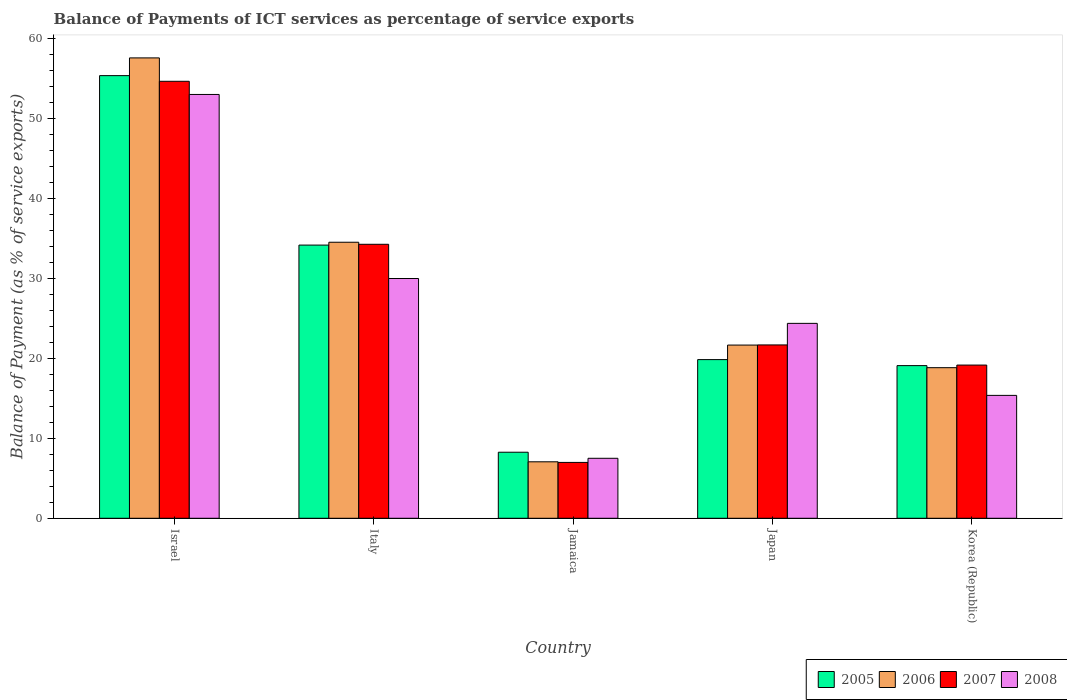Are the number of bars on each tick of the X-axis equal?
Give a very brief answer. Yes. What is the label of the 3rd group of bars from the left?
Give a very brief answer. Jamaica. What is the balance of payments of ICT services in 2006 in Korea (Republic)?
Provide a short and direct response. 18.84. Across all countries, what is the maximum balance of payments of ICT services in 2007?
Provide a succinct answer. 54.67. Across all countries, what is the minimum balance of payments of ICT services in 2007?
Offer a terse response. 6.99. In which country was the balance of payments of ICT services in 2006 maximum?
Give a very brief answer. Israel. In which country was the balance of payments of ICT services in 2005 minimum?
Give a very brief answer. Jamaica. What is the total balance of payments of ICT services in 2008 in the graph?
Ensure brevity in your answer.  130.27. What is the difference between the balance of payments of ICT services in 2007 in Israel and that in Japan?
Make the answer very short. 32.98. What is the difference between the balance of payments of ICT services in 2005 in Italy and the balance of payments of ICT services in 2007 in Korea (Republic)?
Provide a succinct answer. 15.01. What is the average balance of payments of ICT services in 2007 per country?
Provide a short and direct response. 27.36. What is the difference between the balance of payments of ICT services of/in 2008 and balance of payments of ICT services of/in 2006 in Japan?
Offer a terse response. 2.72. What is the ratio of the balance of payments of ICT services in 2007 in Israel to that in Korea (Republic)?
Provide a short and direct response. 2.85. Is the balance of payments of ICT services in 2006 in Italy less than that in Jamaica?
Offer a terse response. No. What is the difference between the highest and the second highest balance of payments of ICT services in 2005?
Make the answer very short. 14.33. What is the difference between the highest and the lowest balance of payments of ICT services in 2006?
Your answer should be very brief. 50.53. Is it the case that in every country, the sum of the balance of payments of ICT services in 2008 and balance of payments of ICT services in 2007 is greater than the balance of payments of ICT services in 2005?
Keep it short and to the point. Yes. How many bars are there?
Your answer should be compact. 20. Are all the bars in the graph horizontal?
Offer a very short reply. No. How many countries are there in the graph?
Offer a very short reply. 5. What is the difference between two consecutive major ticks on the Y-axis?
Provide a short and direct response. 10. Does the graph contain any zero values?
Ensure brevity in your answer.  No. Where does the legend appear in the graph?
Your answer should be very brief. Bottom right. How are the legend labels stacked?
Your answer should be very brief. Horizontal. What is the title of the graph?
Offer a terse response. Balance of Payments of ICT services as percentage of service exports. What is the label or title of the Y-axis?
Make the answer very short. Balance of Payment (as % of service exports). What is the Balance of Payment (as % of service exports) in 2005 in Israel?
Provide a short and direct response. 55.37. What is the Balance of Payment (as % of service exports) of 2006 in Israel?
Make the answer very short. 57.59. What is the Balance of Payment (as % of service exports) of 2007 in Israel?
Keep it short and to the point. 54.67. What is the Balance of Payment (as % of service exports) in 2008 in Israel?
Offer a terse response. 53.02. What is the Balance of Payment (as % of service exports) in 2005 in Italy?
Ensure brevity in your answer.  34.17. What is the Balance of Payment (as % of service exports) of 2006 in Italy?
Make the answer very short. 34.53. What is the Balance of Payment (as % of service exports) in 2007 in Italy?
Give a very brief answer. 34.28. What is the Balance of Payment (as % of service exports) in 2008 in Italy?
Your response must be concise. 29.99. What is the Balance of Payment (as % of service exports) in 2005 in Jamaica?
Provide a succinct answer. 8.26. What is the Balance of Payment (as % of service exports) in 2006 in Jamaica?
Give a very brief answer. 7.06. What is the Balance of Payment (as % of service exports) in 2007 in Jamaica?
Give a very brief answer. 6.99. What is the Balance of Payment (as % of service exports) of 2008 in Jamaica?
Offer a very short reply. 7.5. What is the Balance of Payment (as % of service exports) in 2005 in Japan?
Keep it short and to the point. 19.85. What is the Balance of Payment (as % of service exports) of 2006 in Japan?
Your answer should be compact. 21.67. What is the Balance of Payment (as % of service exports) in 2007 in Japan?
Keep it short and to the point. 21.69. What is the Balance of Payment (as % of service exports) of 2008 in Japan?
Make the answer very short. 24.38. What is the Balance of Payment (as % of service exports) in 2005 in Korea (Republic)?
Your answer should be very brief. 19.1. What is the Balance of Payment (as % of service exports) in 2006 in Korea (Republic)?
Give a very brief answer. 18.84. What is the Balance of Payment (as % of service exports) of 2007 in Korea (Republic)?
Provide a succinct answer. 19.16. What is the Balance of Payment (as % of service exports) in 2008 in Korea (Republic)?
Give a very brief answer. 15.37. Across all countries, what is the maximum Balance of Payment (as % of service exports) in 2005?
Keep it short and to the point. 55.37. Across all countries, what is the maximum Balance of Payment (as % of service exports) in 2006?
Ensure brevity in your answer.  57.59. Across all countries, what is the maximum Balance of Payment (as % of service exports) of 2007?
Keep it short and to the point. 54.67. Across all countries, what is the maximum Balance of Payment (as % of service exports) in 2008?
Provide a short and direct response. 53.02. Across all countries, what is the minimum Balance of Payment (as % of service exports) of 2005?
Make the answer very short. 8.26. Across all countries, what is the minimum Balance of Payment (as % of service exports) of 2006?
Give a very brief answer. 7.06. Across all countries, what is the minimum Balance of Payment (as % of service exports) in 2007?
Make the answer very short. 6.99. Across all countries, what is the minimum Balance of Payment (as % of service exports) in 2008?
Your response must be concise. 7.5. What is the total Balance of Payment (as % of service exports) in 2005 in the graph?
Provide a succinct answer. 136.76. What is the total Balance of Payment (as % of service exports) in 2006 in the graph?
Give a very brief answer. 139.69. What is the total Balance of Payment (as % of service exports) in 2007 in the graph?
Your answer should be very brief. 136.78. What is the total Balance of Payment (as % of service exports) of 2008 in the graph?
Make the answer very short. 130.27. What is the difference between the Balance of Payment (as % of service exports) of 2005 in Israel and that in Italy?
Offer a terse response. 21.2. What is the difference between the Balance of Payment (as % of service exports) in 2006 in Israel and that in Italy?
Your answer should be compact. 23.06. What is the difference between the Balance of Payment (as % of service exports) of 2007 in Israel and that in Italy?
Offer a terse response. 20.39. What is the difference between the Balance of Payment (as % of service exports) in 2008 in Israel and that in Italy?
Keep it short and to the point. 23.02. What is the difference between the Balance of Payment (as % of service exports) in 2005 in Israel and that in Jamaica?
Offer a terse response. 47.11. What is the difference between the Balance of Payment (as % of service exports) of 2006 in Israel and that in Jamaica?
Give a very brief answer. 50.53. What is the difference between the Balance of Payment (as % of service exports) of 2007 in Israel and that in Jamaica?
Offer a terse response. 47.68. What is the difference between the Balance of Payment (as % of service exports) in 2008 in Israel and that in Jamaica?
Offer a very short reply. 45.51. What is the difference between the Balance of Payment (as % of service exports) of 2005 in Israel and that in Japan?
Make the answer very short. 35.52. What is the difference between the Balance of Payment (as % of service exports) in 2006 in Israel and that in Japan?
Give a very brief answer. 35.93. What is the difference between the Balance of Payment (as % of service exports) of 2007 in Israel and that in Japan?
Offer a very short reply. 32.98. What is the difference between the Balance of Payment (as % of service exports) in 2008 in Israel and that in Japan?
Your answer should be very brief. 28.64. What is the difference between the Balance of Payment (as % of service exports) in 2005 in Israel and that in Korea (Republic)?
Offer a very short reply. 36.28. What is the difference between the Balance of Payment (as % of service exports) of 2006 in Israel and that in Korea (Republic)?
Provide a short and direct response. 38.75. What is the difference between the Balance of Payment (as % of service exports) of 2007 in Israel and that in Korea (Republic)?
Give a very brief answer. 35.5. What is the difference between the Balance of Payment (as % of service exports) of 2008 in Israel and that in Korea (Republic)?
Make the answer very short. 37.64. What is the difference between the Balance of Payment (as % of service exports) of 2005 in Italy and that in Jamaica?
Keep it short and to the point. 25.91. What is the difference between the Balance of Payment (as % of service exports) in 2006 in Italy and that in Jamaica?
Offer a terse response. 27.47. What is the difference between the Balance of Payment (as % of service exports) in 2007 in Italy and that in Jamaica?
Keep it short and to the point. 27.29. What is the difference between the Balance of Payment (as % of service exports) in 2008 in Italy and that in Jamaica?
Your answer should be compact. 22.49. What is the difference between the Balance of Payment (as % of service exports) in 2005 in Italy and that in Japan?
Your response must be concise. 14.33. What is the difference between the Balance of Payment (as % of service exports) of 2006 in Italy and that in Japan?
Provide a succinct answer. 12.87. What is the difference between the Balance of Payment (as % of service exports) in 2007 in Italy and that in Japan?
Your answer should be compact. 12.59. What is the difference between the Balance of Payment (as % of service exports) of 2008 in Italy and that in Japan?
Provide a succinct answer. 5.61. What is the difference between the Balance of Payment (as % of service exports) of 2005 in Italy and that in Korea (Republic)?
Keep it short and to the point. 15.08. What is the difference between the Balance of Payment (as % of service exports) of 2006 in Italy and that in Korea (Republic)?
Ensure brevity in your answer.  15.69. What is the difference between the Balance of Payment (as % of service exports) in 2007 in Italy and that in Korea (Republic)?
Provide a succinct answer. 15.11. What is the difference between the Balance of Payment (as % of service exports) of 2008 in Italy and that in Korea (Republic)?
Make the answer very short. 14.62. What is the difference between the Balance of Payment (as % of service exports) of 2005 in Jamaica and that in Japan?
Keep it short and to the point. -11.59. What is the difference between the Balance of Payment (as % of service exports) in 2006 in Jamaica and that in Japan?
Give a very brief answer. -14.6. What is the difference between the Balance of Payment (as % of service exports) of 2007 in Jamaica and that in Japan?
Offer a very short reply. -14.7. What is the difference between the Balance of Payment (as % of service exports) in 2008 in Jamaica and that in Japan?
Provide a succinct answer. -16.88. What is the difference between the Balance of Payment (as % of service exports) of 2005 in Jamaica and that in Korea (Republic)?
Provide a short and direct response. -10.83. What is the difference between the Balance of Payment (as % of service exports) in 2006 in Jamaica and that in Korea (Republic)?
Make the answer very short. -11.78. What is the difference between the Balance of Payment (as % of service exports) of 2007 in Jamaica and that in Korea (Republic)?
Your answer should be very brief. -12.18. What is the difference between the Balance of Payment (as % of service exports) of 2008 in Jamaica and that in Korea (Republic)?
Provide a succinct answer. -7.87. What is the difference between the Balance of Payment (as % of service exports) in 2005 in Japan and that in Korea (Republic)?
Your response must be concise. 0.75. What is the difference between the Balance of Payment (as % of service exports) in 2006 in Japan and that in Korea (Republic)?
Give a very brief answer. 2.83. What is the difference between the Balance of Payment (as % of service exports) of 2007 in Japan and that in Korea (Republic)?
Your response must be concise. 2.52. What is the difference between the Balance of Payment (as % of service exports) in 2008 in Japan and that in Korea (Republic)?
Ensure brevity in your answer.  9.01. What is the difference between the Balance of Payment (as % of service exports) in 2005 in Israel and the Balance of Payment (as % of service exports) in 2006 in Italy?
Give a very brief answer. 20.84. What is the difference between the Balance of Payment (as % of service exports) of 2005 in Israel and the Balance of Payment (as % of service exports) of 2007 in Italy?
Provide a short and direct response. 21.1. What is the difference between the Balance of Payment (as % of service exports) of 2005 in Israel and the Balance of Payment (as % of service exports) of 2008 in Italy?
Provide a short and direct response. 25.38. What is the difference between the Balance of Payment (as % of service exports) in 2006 in Israel and the Balance of Payment (as % of service exports) in 2007 in Italy?
Your answer should be compact. 23.32. What is the difference between the Balance of Payment (as % of service exports) in 2006 in Israel and the Balance of Payment (as % of service exports) in 2008 in Italy?
Make the answer very short. 27.6. What is the difference between the Balance of Payment (as % of service exports) of 2007 in Israel and the Balance of Payment (as % of service exports) of 2008 in Italy?
Your answer should be compact. 24.67. What is the difference between the Balance of Payment (as % of service exports) in 2005 in Israel and the Balance of Payment (as % of service exports) in 2006 in Jamaica?
Keep it short and to the point. 48.31. What is the difference between the Balance of Payment (as % of service exports) of 2005 in Israel and the Balance of Payment (as % of service exports) of 2007 in Jamaica?
Provide a succinct answer. 48.39. What is the difference between the Balance of Payment (as % of service exports) in 2005 in Israel and the Balance of Payment (as % of service exports) in 2008 in Jamaica?
Make the answer very short. 47.87. What is the difference between the Balance of Payment (as % of service exports) of 2006 in Israel and the Balance of Payment (as % of service exports) of 2007 in Jamaica?
Your answer should be very brief. 50.61. What is the difference between the Balance of Payment (as % of service exports) in 2006 in Israel and the Balance of Payment (as % of service exports) in 2008 in Jamaica?
Keep it short and to the point. 50.09. What is the difference between the Balance of Payment (as % of service exports) of 2007 in Israel and the Balance of Payment (as % of service exports) of 2008 in Jamaica?
Ensure brevity in your answer.  47.16. What is the difference between the Balance of Payment (as % of service exports) in 2005 in Israel and the Balance of Payment (as % of service exports) in 2006 in Japan?
Your response must be concise. 33.71. What is the difference between the Balance of Payment (as % of service exports) of 2005 in Israel and the Balance of Payment (as % of service exports) of 2007 in Japan?
Offer a terse response. 33.69. What is the difference between the Balance of Payment (as % of service exports) in 2005 in Israel and the Balance of Payment (as % of service exports) in 2008 in Japan?
Make the answer very short. 30.99. What is the difference between the Balance of Payment (as % of service exports) in 2006 in Israel and the Balance of Payment (as % of service exports) in 2007 in Japan?
Your answer should be very brief. 35.91. What is the difference between the Balance of Payment (as % of service exports) in 2006 in Israel and the Balance of Payment (as % of service exports) in 2008 in Japan?
Offer a terse response. 33.21. What is the difference between the Balance of Payment (as % of service exports) of 2007 in Israel and the Balance of Payment (as % of service exports) of 2008 in Japan?
Your response must be concise. 30.28. What is the difference between the Balance of Payment (as % of service exports) of 2005 in Israel and the Balance of Payment (as % of service exports) of 2006 in Korea (Republic)?
Make the answer very short. 36.53. What is the difference between the Balance of Payment (as % of service exports) in 2005 in Israel and the Balance of Payment (as % of service exports) in 2007 in Korea (Republic)?
Provide a succinct answer. 36.21. What is the difference between the Balance of Payment (as % of service exports) in 2005 in Israel and the Balance of Payment (as % of service exports) in 2008 in Korea (Republic)?
Provide a succinct answer. 40. What is the difference between the Balance of Payment (as % of service exports) in 2006 in Israel and the Balance of Payment (as % of service exports) in 2007 in Korea (Republic)?
Offer a terse response. 38.43. What is the difference between the Balance of Payment (as % of service exports) of 2006 in Israel and the Balance of Payment (as % of service exports) of 2008 in Korea (Republic)?
Offer a terse response. 42.22. What is the difference between the Balance of Payment (as % of service exports) in 2007 in Israel and the Balance of Payment (as % of service exports) in 2008 in Korea (Republic)?
Provide a short and direct response. 39.29. What is the difference between the Balance of Payment (as % of service exports) in 2005 in Italy and the Balance of Payment (as % of service exports) in 2006 in Jamaica?
Give a very brief answer. 27.11. What is the difference between the Balance of Payment (as % of service exports) of 2005 in Italy and the Balance of Payment (as % of service exports) of 2007 in Jamaica?
Your answer should be compact. 27.19. What is the difference between the Balance of Payment (as % of service exports) of 2005 in Italy and the Balance of Payment (as % of service exports) of 2008 in Jamaica?
Keep it short and to the point. 26.67. What is the difference between the Balance of Payment (as % of service exports) in 2006 in Italy and the Balance of Payment (as % of service exports) in 2007 in Jamaica?
Give a very brief answer. 27.54. What is the difference between the Balance of Payment (as % of service exports) of 2006 in Italy and the Balance of Payment (as % of service exports) of 2008 in Jamaica?
Your response must be concise. 27.03. What is the difference between the Balance of Payment (as % of service exports) of 2007 in Italy and the Balance of Payment (as % of service exports) of 2008 in Jamaica?
Provide a succinct answer. 26.77. What is the difference between the Balance of Payment (as % of service exports) of 2005 in Italy and the Balance of Payment (as % of service exports) of 2006 in Japan?
Your answer should be compact. 12.51. What is the difference between the Balance of Payment (as % of service exports) in 2005 in Italy and the Balance of Payment (as % of service exports) in 2007 in Japan?
Provide a succinct answer. 12.49. What is the difference between the Balance of Payment (as % of service exports) of 2005 in Italy and the Balance of Payment (as % of service exports) of 2008 in Japan?
Provide a short and direct response. 9.79. What is the difference between the Balance of Payment (as % of service exports) in 2006 in Italy and the Balance of Payment (as % of service exports) in 2007 in Japan?
Offer a very short reply. 12.85. What is the difference between the Balance of Payment (as % of service exports) of 2006 in Italy and the Balance of Payment (as % of service exports) of 2008 in Japan?
Give a very brief answer. 10.15. What is the difference between the Balance of Payment (as % of service exports) in 2007 in Italy and the Balance of Payment (as % of service exports) in 2008 in Japan?
Provide a succinct answer. 9.89. What is the difference between the Balance of Payment (as % of service exports) in 2005 in Italy and the Balance of Payment (as % of service exports) in 2006 in Korea (Republic)?
Your answer should be very brief. 15.34. What is the difference between the Balance of Payment (as % of service exports) in 2005 in Italy and the Balance of Payment (as % of service exports) in 2007 in Korea (Republic)?
Provide a short and direct response. 15.01. What is the difference between the Balance of Payment (as % of service exports) in 2005 in Italy and the Balance of Payment (as % of service exports) in 2008 in Korea (Republic)?
Your answer should be compact. 18.8. What is the difference between the Balance of Payment (as % of service exports) of 2006 in Italy and the Balance of Payment (as % of service exports) of 2007 in Korea (Republic)?
Give a very brief answer. 15.37. What is the difference between the Balance of Payment (as % of service exports) in 2006 in Italy and the Balance of Payment (as % of service exports) in 2008 in Korea (Republic)?
Keep it short and to the point. 19.16. What is the difference between the Balance of Payment (as % of service exports) of 2007 in Italy and the Balance of Payment (as % of service exports) of 2008 in Korea (Republic)?
Provide a short and direct response. 18.9. What is the difference between the Balance of Payment (as % of service exports) of 2005 in Jamaica and the Balance of Payment (as % of service exports) of 2006 in Japan?
Provide a short and direct response. -13.4. What is the difference between the Balance of Payment (as % of service exports) of 2005 in Jamaica and the Balance of Payment (as % of service exports) of 2007 in Japan?
Keep it short and to the point. -13.42. What is the difference between the Balance of Payment (as % of service exports) of 2005 in Jamaica and the Balance of Payment (as % of service exports) of 2008 in Japan?
Offer a very short reply. -16.12. What is the difference between the Balance of Payment (as % of service exports) in 2006 in Jamaica and the Balance of Payment (as % of service exports) in 2007 in Japan?
Make the answer very short. -14.62. What is the difference between the Balance of Payment (as % of service exports) of 2006 in Jamaica and the Balance of Payment (as % of service exports) of 2008 in Japan?
Provide a short and direct response. -17.32. What is the difference between the Balance of Payment (as % of service exports) in 2007 in Jamaica and the Balance of Payment (as % of service exports) in 2008 in Japan?
Offer a terse response. -17.39. What is the difference between the Balance of Payment (as % of service exports) of 2005 in Jamaica and the Balance of Payment (as % of service exports) of 2006 in Korea (Republic)?
Keep it short and to the point. -10.58. What is the difference between the Balance of Payment (as % of service exports) of 2005 in Jamaica and the Balance of Payment (as % of service exports) of 2007 in Korea (Republic)?
Offer a terse response. -10.9. What is the difference between the Balance of Payment (as % of service exports) in 2005 in Jamaica and the Balance of Payment (as % of service exports) in 2008 in Korea (Republic)?
Make the answer very short. -7.11. What is the difference between the Balance of Payment (as % of service exports) of 2006 in Jamaica and the Balance of Payment (as % of service exports) of 2007 in Korea (Republic)?
Make the answer very short. -12.1. What is the difference between the Balance of Payment (as % of service exports) in 2006 in Jamaica and the Balance of Payment (as % of service exports) in 2008 in Korea (Republic)?
Keep it short and to the point. -8.31. What is the difference between the Balance of Payment (as % of service exports) in 2007 in Jamaica and the Balance of Payment (as % of service exports) in 2008 in Korea (Republic)?
Offer a very short reply. -8.39. What is the difference between the Balance of Payment (as % of service exports) of 2005 in Japan and the Balance of Payment (as % of service exports) of 2006 in Korea (Republic)?
Make the answer very short. 1.01. What is the difference between the Balance of Payment (as % of service exports) of 2005 in Japan and the Balance of Payment (as % of service exports) of 2007 in Korea (Republic)?
Give a very brief answer. 0.68. What is the difference between the Balance of Payment (as % of service exports) in 2005 in Japan and the Balance of Payment (as % of service exports) in 2008 in Korea (Republic)?
Provide a succinct answer. 4.48. What is the difference between the Balance of Payment (as % of service exports) of 2006 in Japan and the Balance of Payment (as % of service exports) of 2007 in Korea (Republic)?
Provide a succinct answer. 2.5. What is the difference between the Balance of Payment (as % of service exports) in 2006 in Japan and the Balance of Payment (as % of service exports) in 2008 in Korea (Republic)?
Offer a very short reply. 6.29. What is the difference between the Balance of Payment (as % of service exports) of 2007 in Japan and the Balance of Payment (as % of service exports) of 2008 in Korea (Republic)?
Make the answer very short. 6.31. What is the average Balance of Payment (as % of service exports) of 2005 per country?
Your answer should be very brief. 27.35. What is the average Balance of Payment (as % of service exports) of 2006 per country?
Give a very brief answer. 27.94. What is the average Balance of Payment (as % of service exports) in 2007 per country?
Provide a succinct answer. 27.36. What is the average Balance of Payment (as % of service exports) in 2008 per country?
Ensure brevity in your answer.  26.05. What is the difference between the Balance of Payment (as % of service exports) in 2005 and Balance of Payment (as % of service exports) in 2006 in Israel?
Make the answer very short. -2.22. What is the difference between the Balance of Payment (as % of service exports) in 2005 and Balance of Payment (as % of service exports) in 2007 in Israel?
Provide a short and direct response. 0.71. What is the difference between the Balance of Payment (as % of service exports) of 2005 and Balance of Payment (as % of service exports) of 2008 in Israel?
Provide a short and direct response. 2.36. What is the difference between the Balance of Payment (as % of service exports) of 2006 and Balance of Payment (as % of service exports) of 2007 in Israel?
Your answer should be very brief. 2.93. What is the difference between the Balance of Payment (as % of service exports) in 2006 and Balance of Payment (as % of service exports) in 2008 in Israel?
Provide a succinct answer. 4.57. What is the difference between the Balance of Payment (as % of service exports) of 2007 and Balance of Payment (as % of service exports) of 2008 in Israel?
Your answer should be compact. 1.65. What is the difference between the Balance of Payment (as % of service exports) in 2005 and Balance of Payment (as % of service exports) in 2006 in Italy?
Ensure brevity in your answer.  -0.36. What is the difference between the Balance of Payment (as % of service exports) of 2005 and Balance of Payment (as % of service exports) of 2007 in Italy?
Your answer should be very brief. -0.1. What is the difference between the Balance of Payment (as % of service exports) in 2005 and Balance of Payment (as % of service exports) in 2008 in Italy?
Your response must be concise. 4.18. What is the difference between the Balance of Payment (as % of service exports) of 2006 and Balance of Payment (as % of service exports) of 2007 in Italy?
Offer a terse response. 0.26. What is the difference between the Balance of Payment (as % of service exports) in 2006 and Balance of Payment (as % of service exports) in 2008 in Italy?
Offer a terse response. 4.54. What is the difference between the Balance of Payment (as % of service exports) of 2007 and Balance of Payment (as % of service exports) of 2008 in Italy?
Provide a succinct answer. 4.28. What is the difference between the Balance of Payment (as % of service exports) of 2005 and Balance of Payment (as % of service exports) of 2006 in Jamaica?
Ensure brevity in your answer.  1.2. What is the difference between the Balance of Payment (as % of service exports) of 2005 and Balance of Payment (as % of service exports) of 2007 in Jamaica?
Give a very brief answer. 1.28. What is the difference between the Balance of Payment (as % of service exports) in 2005 and Balance of Payment (as % of service exports) in 2008 in Jamaica?
Offer a very short reply. 0.76. What is the difference between the Balance of Payment (as % of service exports) of 2006 and Balance of Payment (as % of service exports) of 2007 in Jamaica?
Give a very brief answer. 0.08. What is the difference between the Balance of Payment (as % of service exports) of 2006 and Balance of Payment (as % of service exports) of 2008 in Jamaica?
Your answer should be very brief. -0.44. What is the difference between the Balance of Payment (as % of service exports) of 2007 and Balance of Payment (as % of service exports) of 2008 in Jamaica?
Offer a terse response. -0.52. What is the difference between the Balance of Payment (as % of service exports) of 2005 and Balance of Payment (as % of service exports) of 2006 in Japan?
Provide a short and direct response. -1.82. What is the difference between the Balance of Payment (as % of service exports) in 2005 and Balance of Payment (as % of service exports) in 2007 in Japan?
Provide a short and direct response. -1.84. What is the difference between the Balance of Payment (as % of service exports) of 2005 and Balance of Payment (as % of service exports) of 2008 in Japan?
Your answer should be compact. -4.53. What is the difference between the Balance of Payment (as % of service exports) of 2006 and Balance of Payment (as % of service exports) of 2007 in Japan?
Ensure brevity in your answer.  -0.02. What is the difference between the Balance of Payment (as % of service exports) in 2006 and Balance of Payment (as % of service exports) in 2008 in Japan?
Ensure brevity in your answer.  -2.72. What is the difference between the Balance of Payment (as % of service exports) in 2007 and Balance of Payment (as % of service exports) in 2008 in Japan?
Your response must be concise. -2.7. What is the difference between the Balance of Payment (as % of service exports) in 2005 and Balance of Payment (as % of service exports) in 2006 in Korea (Republic)?
Offer a very short reply. 0.26. What is the difference between the Balance of Payment (as % of service exports) in 2005 and Balance of Payment (as % of service exports) in 2007 in Korea (Republic)?
Keep it short and to the point. -0.07. What is the difference between the Balance of Payment (as % of service exports) of 2005 and Balance of Payment (as % of service exports) of 2008 in Korea (Republic)?
Keep it short and to the point. 3.72. What is the difference between the Balance of Payment (as % of service exports) in 2006 and Balance of Payment (as % of service exports) in 2007 in Korea (Republic)?
Your answer should be compact. -0.33. What is the difference between the Balance of Payment (as % of service exports) in 2006 and Balance of Payment (as % of service exports) in 2008 in Korea (Republic)?
Your answer should be very brief. 3.46. What is the difference between the Balance of Payment (as % of service exports) in 2007 and Balance of Payment (as % of service exports) in 2008 in Korea (Republic)?
Your answer should be very brief. 3.79. What is the ratio of the Balance of Payment (as % of service exports) in 2005 in Israel to that in Italy?
Offer a terse response. 1.62. What is the ratio of the Balance of Payment (as % of service exports) in 2006 in Israel to that in Italy?
Give a very brief answer. 1.67. What is the ratio of the Balance of Payment (as % of service exports) of 2007 in Israel to that in Italy?
Make the answer very short. 1.59. What is the ratio of the Balance of Payment (as % of service exports) of 2008 in Israel to that in Italy?
Offer a very short reply. 1.77. What is the ratio of the Balance of Payment (as % of service exports) in 2005 in Israel to that in Jamaica?
Offer a very short reply. 6.7. What is the ratio of the Balance of Payment (as % of service exports) in 2006 in Israel to that in Jamaica?
Provide a succinct answer. 8.15. What is the ratio of the Balance of Payment (as % of service exports) of 2007 in Israel to that in Jamaica?
Your answer should be compact. 7.82. What is the ratio of the Balance of Payment (as % of service exports) of 2008 in Israel to that in Jamaica?
Your answer should be compact. 7.07. What is the ratio of the Balance of Payment (as % of service exports) of 2005 in Israel to that in Japan?
Keep it short and to the point. 2.79. What is the ratio of the Balance of Payment (as % of service exports) in 2006 in Israel to that in Japan?
Provide a short and direct response. 2.66. What is the ratio of the Balance of Payment (as % of service exports) in 2007 in Israel to that in Japan?
Keep it short and to the point. 2.52. What is the ratio of the Balance of Payment (as % of service exports) in 2008 in Israel to that in Japan?
Provide a succinct answer. 2.17. What is the ratio of the Balance of Payment (as % of service exports) in 2005 in Israel to that in Korea (Republic)?
Keep it short and to the point. 2.9. What is the ratio of the Balance of Payment (as % of service exports) of 2006 in Israel to that in Korea (Republic)?
Your response must be concise. 3.06. What is the ratio of the Balance of Payment (as % of service exports) of 2007 in Israel to that in Korea (Republic)?
Offer a very short reply. 2.85. What is the ratio of the Balance of Payment (as % of service exports) of 2008 in Israel to that in Korea (Republic)?
Your answer should be compact. 3.45. What is the ratio of the Balance of Payment (as % of service exports) in 2005 in Italy to that in Jamaica?
Offer a very short reply. 4.14. What is the ratio of the Balance of Payment (as % of service exports) in 2006 in Italy to that in Jamaica?
Your response must be concise. 4.89. What is the ratio of the Balance of Payment (as % of service exports) of 2007 in Italy to that in Jamaica?
Make the answer very short. 4.91. What is the ratio of the Balance of Payment (as % of service exports) in 2008 in Italy to that in Jamaica?
Your answer should be very brief. 4. What is the ratio of the Balance of Payment (as % of service exports) of 2005 in Italy to that in Japan?
Your answer should be very brief. 1.72. What is the ratio of the Balance of Payment (as % of service exports) in 2006 in Italy to that in Japan?
Keep it short and to the point. 1.59. What is the ratio of the Balance of Payment (as % of service exports) of 2007 in Italy to that in Japan?
Give a very brief answer. 1.58. What is the ratio of the Balance of Payment (as % of service exports) in 2008 in Italy to that in Japan?
Give a very brief answer. 1.23. What is the ratio of the Balance of Payment (as % of service exports) of 2005 in Italy to that in Korea (Republic)?
Your answer should be very brief. 1.79. What is the ratio of the Balance of Payment (as % of service exports) of 2006 in Italy to that in Korea (Republic)?
Your answer should be compact. 1.83. What is the ratio of the Balance of Payment (as % of service exports) of 2007 in Italy to that in Korea (Republic)?
Make the answer very short. 1.79. What is the ratio of the Balance of Payment (as % of service exports) in 2008 in Italy to that in Korea (Republic)?
Keep it short and to the point. 1.95. What is the ratio of the Balance of Payment (as % of service exports) in 2005 in Jamaica to that in Japan?
Ensure brevity in your answer.  0.42. What is the ratio of the Balance of Payment (as % of service exports) in 2006 in Jamaica to that in Japan?
Your answer should be compact. 0.33. What is the ratio of the Balance of Payment (as % of service exports) in 2007 in Jamaica to that in Japan?
Provide a short and direct response. 0.32. What is the ratio of the Balance of Payment (as % of service exports) of 2008 in Jamaica to that in Japan?
Offer a terse response. 0.31. What is the ratio of the Balance of Payment (as % of service exports) in 2005 in Jamaica to that in Korea (Republic)?
Make the answer very short. 0.43. What is the ratio of the Balance of Payment (as % of service exports) in 2006 in Jamaica to that in Korea (Republic)?
Give a very brief answer. 0.37. What is the ratio of the Balance of Payment (as % of service exports) in 2007 in Jamaica to that in Korea (Republic)?
Ensure brevity in your answer.  0.36. What is the ratio of the Balance of Payment (as % of service exports) of 2008 in Jamaica to that in Korea (Republic)?
Your answer should be very brief. 0.49. What is the ratio of the Balance of Payment (as % of service exports) of 2005 in Japan to that in Korea (Republic)?
Keep it short and to the point. 1.04. What is the ratio of the Balance of Payment (as % of service exports) of 2006 in Japan to that in Korea (Republic)?
Your answer should be very brief. 1.15. What is the ratio of the Balance of Payment (as % of service exports) of 2007 in Japan to that in Korea (Republic)?
Give a very brief answer. 1.13. What is the ratio of the Balance of Payment (as % of service exports) of 2008 in Japan to that in Korea (Republic)?
Make the answer very short. 1.59. What is the difference between the highest and the second highest Balance of Payment (as % of service exports) in 2005?
Ensure brevity in your answer.  21.2. What is the difference between the highest and the second highest Balance of Payment (as % of service exports) of 2006?
Provide a succinct answer. 23.06. What is the difference between the highest and the second highest Balance of Payment (as % of service exports) of 2007?
Provide a succinct answer. 20.39. What is the difference between the highest and the second highest Balance of Payment (as % of service exports) of 2008?
Offer a very short reply. 23.02. What is the difference between the highest and the lowest Balance of Payment (as % of service exports) of 2005?
Provide a short and direct response. 47.11. What is the difference between the highest and the lowest Balance of Payment (as % of service exports) of 2006?
Offer a very short reply. 50.53. What is the difference between the highest and the lowest Balance of Payment (as % of service exports) in 2007?
Your response must be concise. 47.68. What is the difference between the highest and the lowest Balance of Payment (as % of service exports) in 2008?
Make the answer very short. 45.51. 